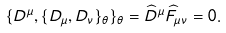<formula> <loc_0><loc_0><loc_500><loc_500>\{ D ^ { \mu } , \{ D _ { \mu } , D _ { \nu } \} _ { \theta } \} _ { \theta } = \widehat { D } ^ { \mu } \widehat { F } _ { \mu \nu } = 0 .</formula> 